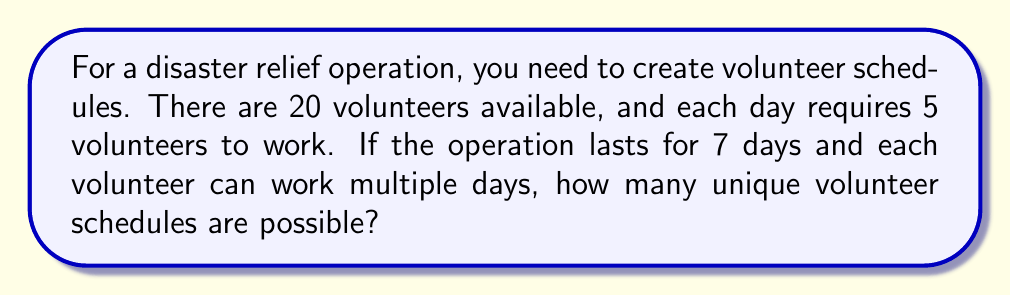What is the answer to this math problem? Let's approach this step-by-step:

1) For each day, we need to choose 5 volunteers out of 20. This is a combination problem.

2) The number of ways to choose 5 volunteers out of 20 for a single day is:

   $$\binom{20}{5} = \frac{20!}{5!(20-5)!} = \frac{20!}{5!15!} = 15,504$$

3) We need to make this choice for each of the 7 days, and the choices for each day are independent of the others.

4) When we have independent events, we multiply the number of possibilities for each event.

5) Therefore, the total number of possible schedules is:

   $$15,504^7$$

6) Let's calculate this:

   $$15,504^7 = 1.32 \times 10^{30}$$ (rounded to 2 significant figures)

This extremely large number represents all possible schedules, including those where some volunteers might work every day and others might not work at all. In practice, you'd likely want to implement additional constraints to ensure a more balanced distribution of work.
Answer: $1.32 \times 10^{30}$ 